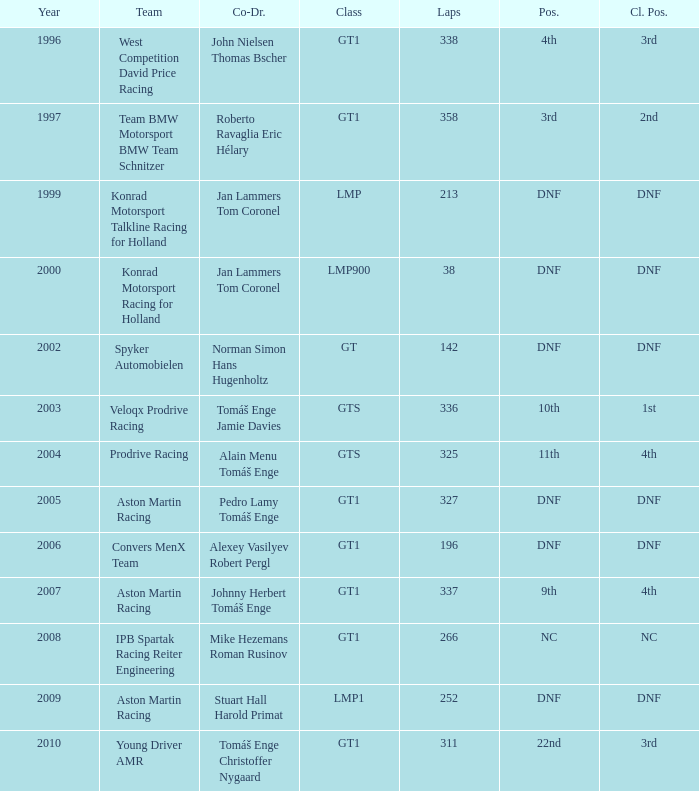In which class had 252 laps and a position of dnf? LMP1. 